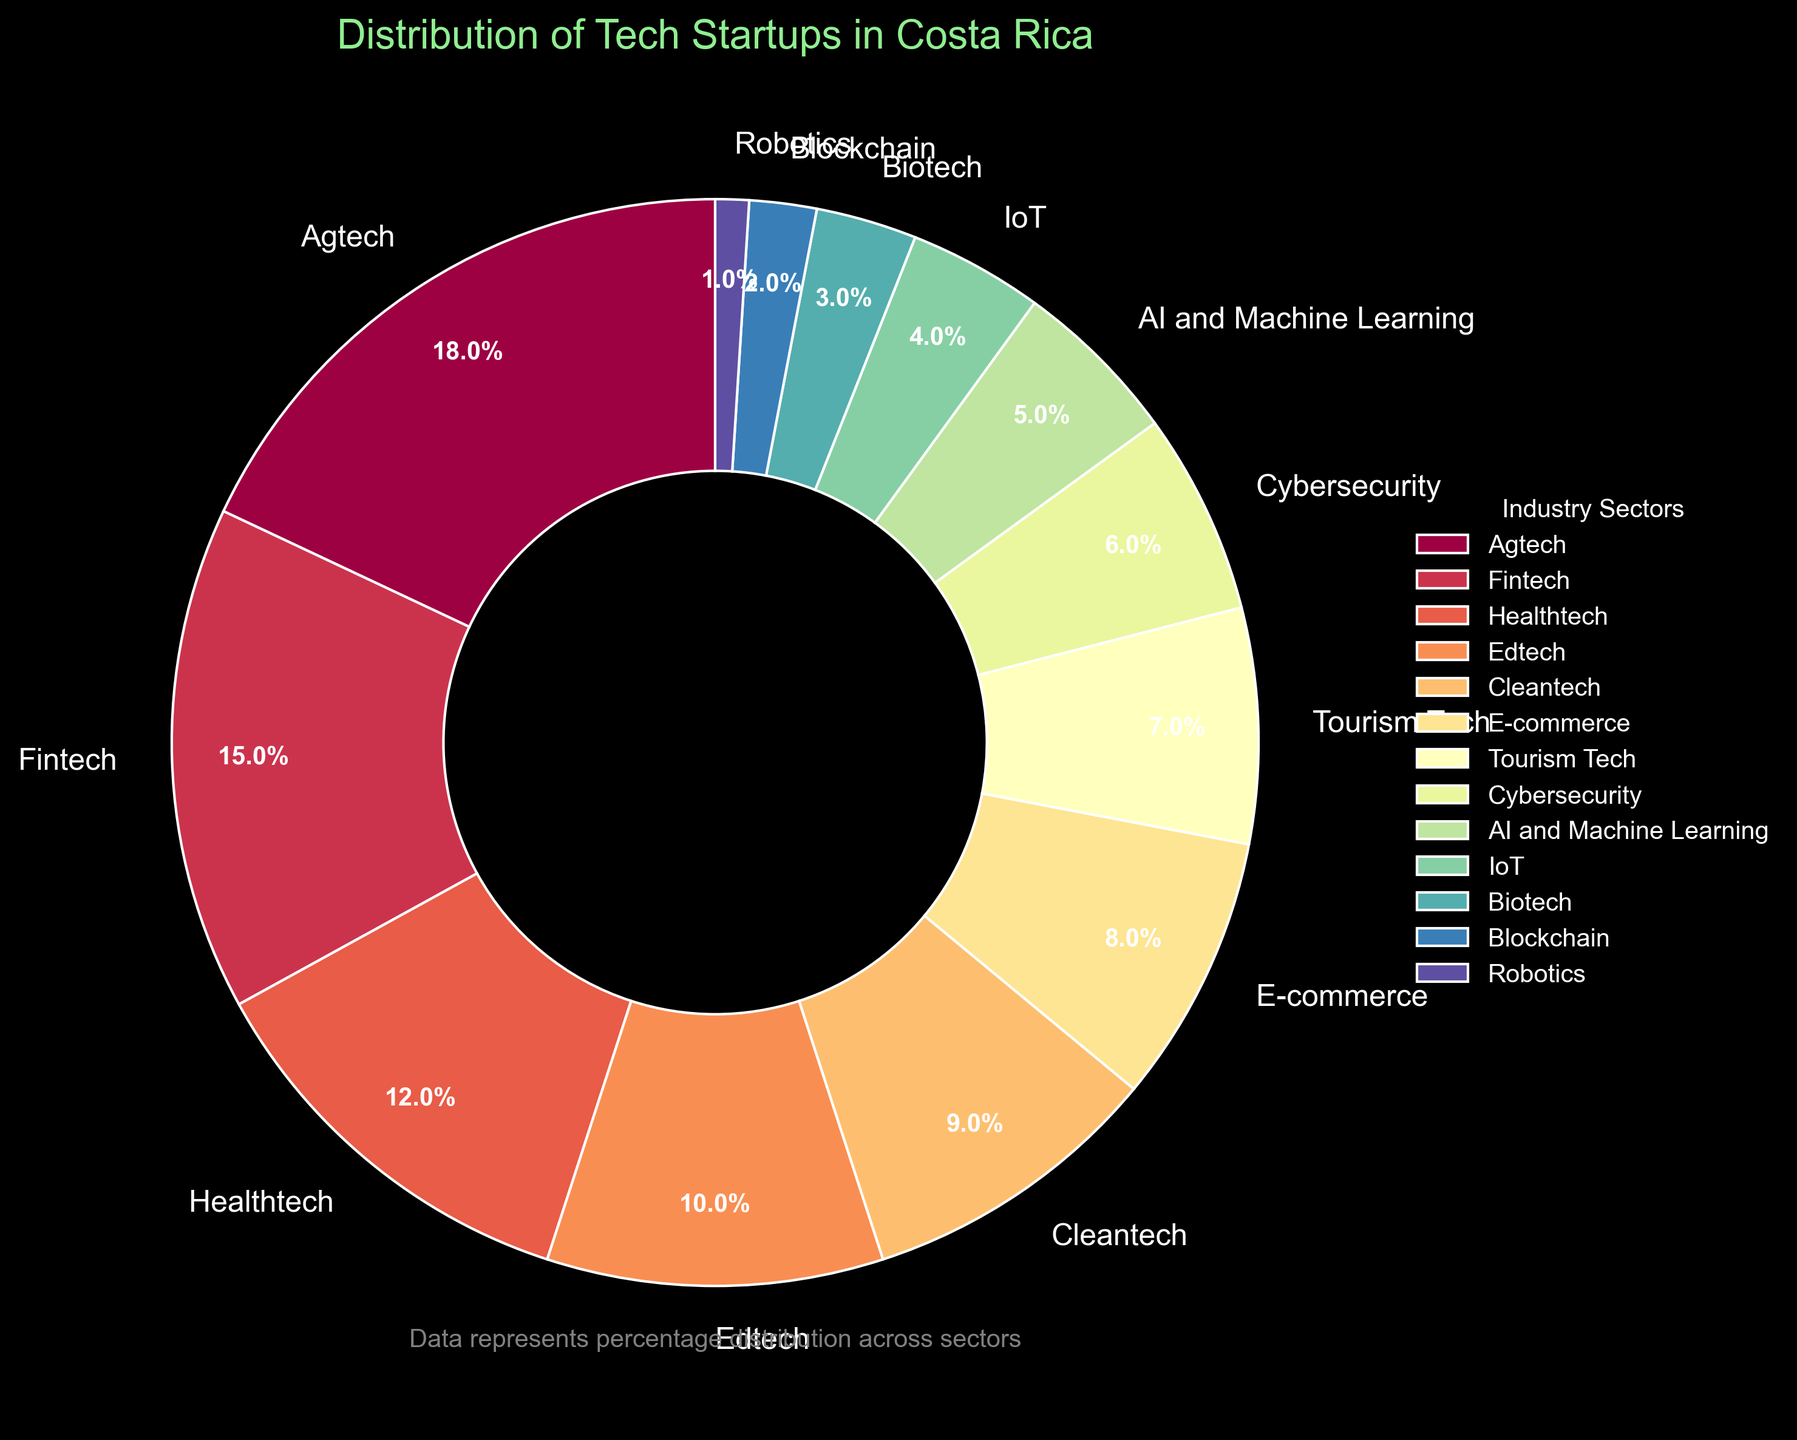Which sector has the largest share of tech startups in Costa Rica? The share of each tech startup sector is displayed on the pie chart. The largest wedge corresponds to Agtech.
Answer: Agtech What is the total percentage of startups in the Fintech and Healthtech sectors combined? Locate the percentages for Fintech (15%) and Healthtech (12%) on the pie chart and sum them up: 15 + 12 = 27.
Answer: 27% Which sector has the smallest share of tech startups? The pie chart shows that the smallest wedge belongs to Robotics.
Answer: Robotics How many sectors have a percentage share of 10% or greater? Identify and count the sectors with a percentage of 10% or more: Agtech (18%), Fintech (15%), Healthtech (12%), and Edtech (10%). The count is 4.
Answer: 4 Is the share of E-commerce startups greater than that of Cybersecurity startups? Compare the percentage share for E-commerce (8%) and Cybersecurity (6%) as shown on the pie chart. Yes, 8% is greater than 6%.
Answer: Yes What is the average percentage share of the Cleantech, E-commerce, and Tourism Tech sectors? Find the percentages for Cleantech (9%), E-commerce (8%), and Tourism Tech (7%). Sum these up and divide by 3: (9 + 8 + 7) / 3 = 8.
Answer: 8% By how much does the percentage of Agtech startups exceed that of Blockchain startups? Calculate the difference between Agtech (18%) and Blockchain (2%) shares: 18 - 2 = 16.
Answer: 16% Which sectors have a share less than 5% and what is their total combined percentage? Locate sectors with percentages under 5%: IoT (4%), Biotech (3%), Blockchain (2%), Robotics (1%). Sum these: 4 + 3 + 2 + 1 = 10.
Answer: IoT, Biotech, Blockchain, Robotics; 10% Are there more tech startups in the Fintech sector or in the combined sectors of AI and Machine Learning, and IoT? Compare Fintech's share (15%) with the combined share of AI and Machine Learning (5%) and IoT (4%): 5 + 4 = 9, and 15 is greater than 9.
Answer: Fintech What is the percentage difference between Healthtech and IoT sectors? Subtract the IoT percentage (4%) from Healthtech (12%): 12 - 4 = 8.
Answer: 8% 